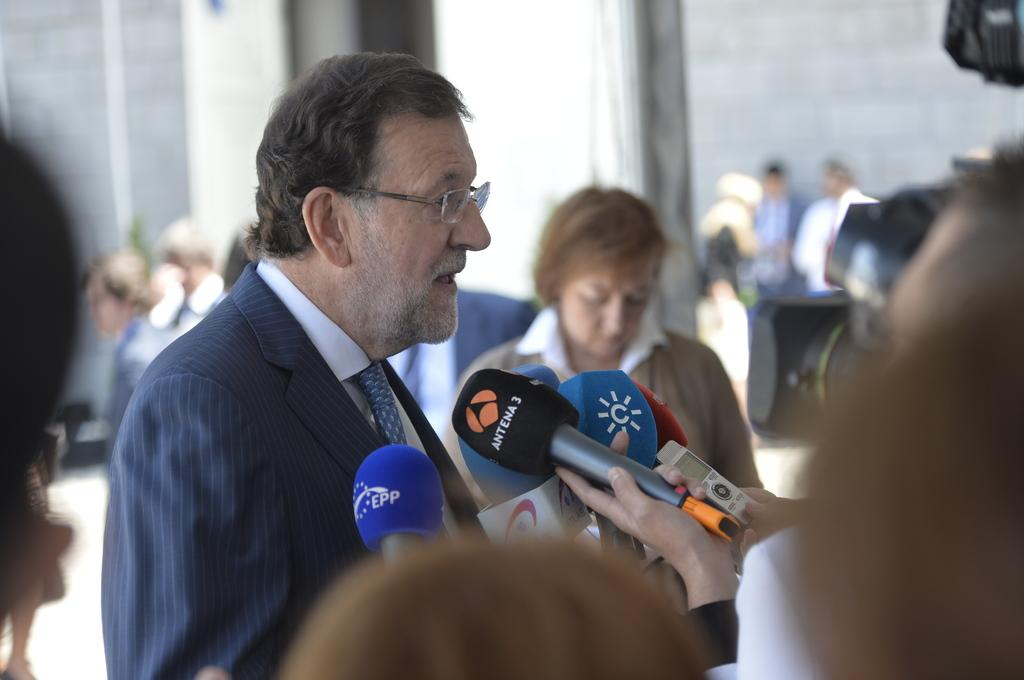What is the person in the image wearing on their face? The person in the image is wearing glasses. What is the person doing in the image? The person is standing and talking. What object is the person in front of? The person is in front of a microphone. Are there any other people in the image? Yes, there are other people in the image. How is the background of the image depicted? The background of the image is blurred. What type of art can be seen on the oven in the image? There is no oven or art present in the image. How does the steam affect the person's speech in the image? There is no steam present in the image, so it does not affect the person's speech. 